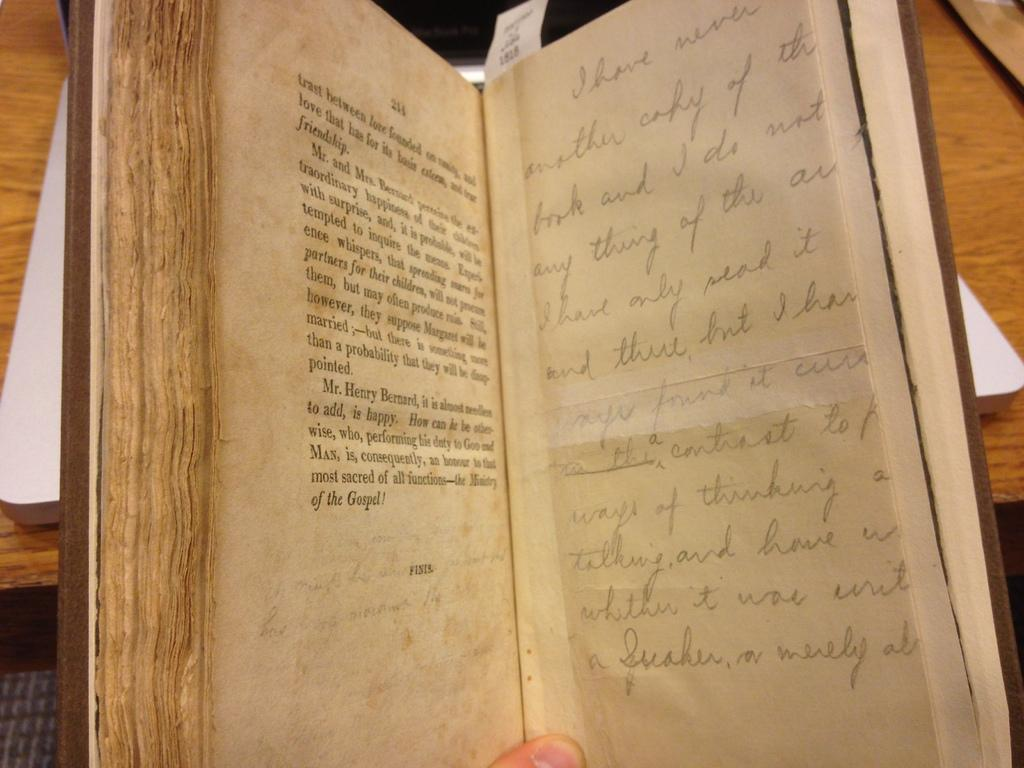<image>
Present a compact description of the photo's key features. A book is open to a page that starts with the word trast. 